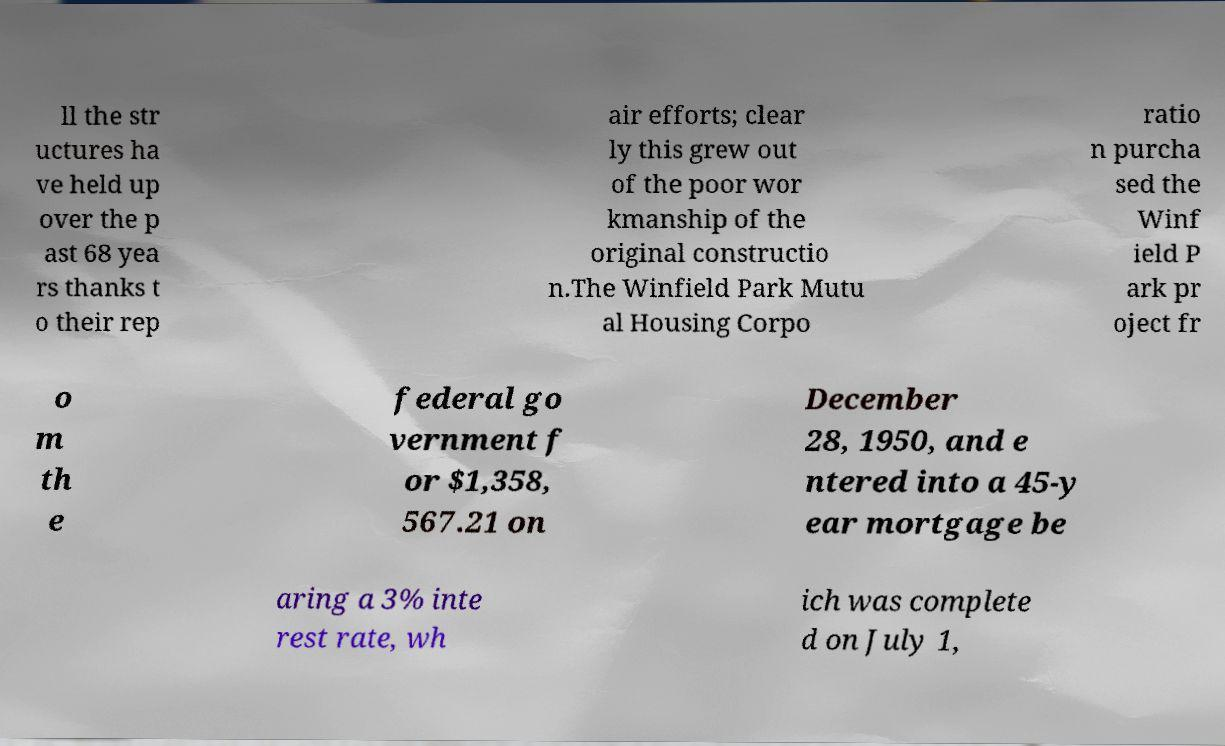Could you extract and type out the text from this image? ll the str uctures ha ve held up over the p ast 68 yea rs thanks t o their rep air efforts; clear ly this grew out of the poor wor kmanship of the original constructio n.The Winfield Park Mutu al Housing Corpo ratio n purcha sed the Winf ield P ark pr oject fr o m th e federal go vernment f or $1,358, 567.21 on December 28, 1950, and e ntered into a 45-y ear mortgage be aring a 3% inte rest rate, wh ich was complete d on July 1, 